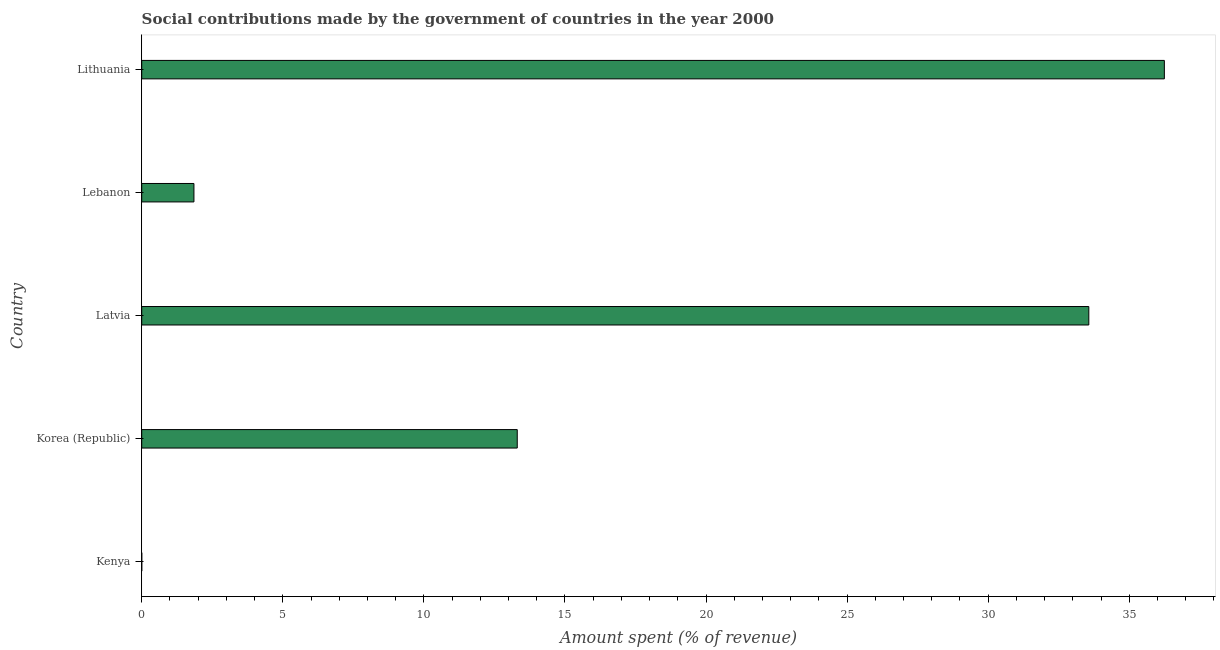What is the title of the graph?
Offer a very short reply. Social contributions made by the government of countries in the year 2000. What is the label or title of the X-axis?
Make the answer very short. Amount spent (% of revenue). What is the label or title of the Y-axis?
Provide a short and direct response. Country. What is the amount spent in making social contributions in Lithuania?
Give a very brief answer. 36.25. Across all countries, what is the maximum amount spent in making social contributions?
Give a very brief answer. 36.25. Across all countries, what is the minimum amount spent in making social contributions?
Give a very brief answer. 0. In which country was the amount spent in making social contributions maximum?
Your response must be concise. Lithuania. In which country was the amount spent in making social contributions minimum?
Provide a short and direct response. Kenya. What is the sum of the amount spent in making social contributions?
Your response must be concise. 84.98. What is the difference between the amount spent in making social contributions in Kenya and Latvia?
Your answer should be very brief. -33.57. What is the average amount spent in making social contributions per country?
Keep it short and to the point. 17. What is the median amount spent in making social contributions?
Provide a short and direct response. 13.31. What is the ratio of the amount spent in making social contributions in Korea (Republic) to that in Latvia?
Make the answer very short. 0.4. Is the amount spent in making social contributions in Kenya less than that in Lebanon?
Give a very brief answer. Yes. Is the difference between the amount spent in making social contributions in Korea (Republic) and Latvia greater than the difference between any two countries?
Offer a very short reply. No. What is the difference between the highest and the second highest amount spent in making social contributions?
Keep it short and to the point. 2.68. What is the difference between the highest and the lowest amount spent in making social contributions?
Offer a terse response. 36.24. In how many countries, is the amount spent in making social contributions greater than the average amount spent in making social contributions taken over all countries?
Provide a succinct answer. 2. Are the values on the major ticks of X-axis written in scientific E-notation?
Give a very brief answer. No. What is the Amount spent (% of revenue) in Kenya?
Provide a short and direct response. 0. What is the Amount spent (% of revenue) in Korea (Republic)?
Keep it short and to the point. 13.31. What is the Amount spent (% of revenue) of Latvia?
Offer a terse response. 33.57. What is the Amount spent (% of revenue) of Lebanon?
Provide a succinct answer. 1.85. What is the Amount spent (% of revenue) in Lithuania?
Offer a very short reply. 36.25. What is the difference between the Amount spent (% of revenue) in Kenya and Korea (Republic)?
Give a very brief answer. -13.31. What is the difference between the Amount spent (% of revenue) in Kenya and Latvia?
Keep it short and to the point. -33.57. What is the difference between the Amount spent (% of revenue) in Kenya and Lebanon?
Give a very brief answer. -1.85. What is the difference between the Amount spent (% of revenue) in Kenya and Lithuania?
Give a very brief answer. -36.24. What is the difference between the Amount spent (% of revenue) in Korea (Republic) and Latvia?
Make the answer very short. -20.26. What is the difference between the Amount spent (% of revenue) in Korea (Republic) and Lebanon?
Your answer should be very brief. 11.46. What is the difference between the Amount spent (% of revenue) in Korea (Republic) and Lithuania?
Give a very brief answer. -22.94. What is the difference between the Amount spent (% of revenue) in Latvia and Lebanon?
Provide a short and direct response. 31.72. What is the difference between the Amount spent (% of revenue) in Latvia and Lithuania?
Keep it short and to the point. -2.68. What is the difference between the Amount spent (% of revenue) in Lebanon and Lithuania?
Give a very brief answer. -34.4. What is the ratio of the Amount spent (% of revenue) in Kenya to that in Latvia?
Provide a succinct answer. 0. What is the ratio of the Amount spent (% of revenue) in Kenya to that in Lebanon?
Ensure brevity in your answer.  0. What is the ratio of the Amount spent (% of revenue) in Kenya to that in Lithuania?
Offer a very short reply. 0. What is the ratio of the Amount spent (% of revenue) in Korea (Republic) to that in Latvia?
Your answer should be very brief. 0.4. What is the ratio of the Amount spent (% of revenue) in Korea (Republic) to that in Lebanon?
Keep it short and to the point. 7.19. What is the ratio of the Amount spent (% of revenue) in Korea (Republic) to that in Lithuania?
Provide a short and direct response. 0.37. What is the ratio of the Amount spent (% of revenue) in Latvia to that in Lebanon?
Provide a short and direct response. 18.14. What is the ratio of the Amount spent (% of revenue) in Latvia to that in Lithuania?
Ensure brevity in your answer.  0.93. What is the ratio of the Amount spent (% of revenue) in Lebanon to that in Lithuania?
Provide a succinct answer. 0.05. 